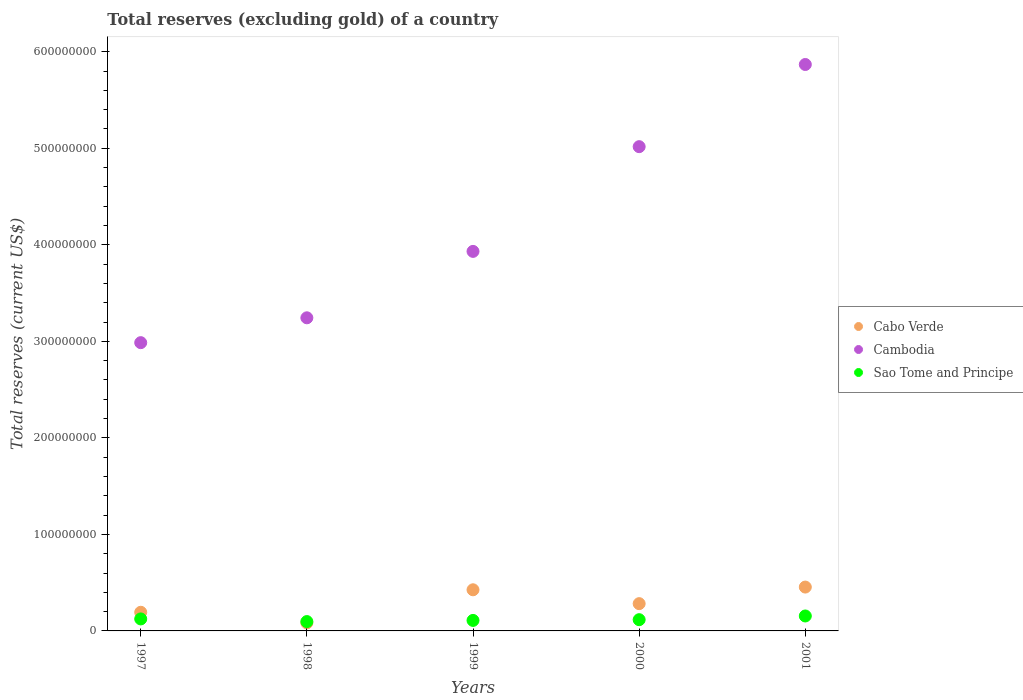What is the total reserves (excluding gold) in Sao Tome and Principe in 2001?
Offer a very short reply. 1.55e+07. Across all years, what is the maximum total reserves (excluding gold) in Sao Tome and Principe?
Ensure brevity in your answer.  1.55e+07. Across all years, what is the minimum total reserves (excluding gold) in Cambodia?
Your answer should be compact. 2.99e+08. In which year was the total reserves (excluding gold) in Cambodia maximum?
Offer a very short reply. 2001. What is the total total reserves (excluding gold) in Cabo Verde in the graph?
Provide a succinct answer. 1.44e+08. What is the difference between the total reserves (excluding gold) in Cambodia in 2000 and that in 2001?
Your answer should be compact. -8.51e+07. What is the difference between the total reserves (excluding gold) in Cabo Verde in 1999 and the total reserves (excluding gold) in Sao Tome and Principe in 2000?
Your answer should be very brief. 3.10e+07. What is the average total reserves (excluding gold) in Sao Tome and Principe per year?
Offer a terse response. 1.20e+07. In the year 2001, what is the difference between the total reserves (excluding gold) in Cabo Verde and total reserves (excluding gold) in Sao Tome and Principe?
Provide a short and direct response. 2.99e+07. What is the ratio of the total reserves (excluding gold) in Sao Tome and Principe in 1998 to that in 1999?
Provide a short and direct response. 0.89. Is the total reserves (excluding gold) in Cabo Verde in 1999 less than that in 2000?
Make the answer very short. No. Is the difference between the total reserves (excluding gold) in Cabo Verde in 1999 and 2000 greater than the difference between the total reserves (excluding gold) in Sao Tome and Principe in 1999 and 2000?
Offer a terse response. Yes. What is the difference between the highest and the second highest total reserves (excluding gold) in Sao Tome and Principe?
Provide a succinct answer. 3.06e+06. What is the difference between the highest and the lowest total reserves (excluding gold) in Sao Tome and Principe?
Provide a short and direct response. 5.80e+06. In how many years, is the total reserves (excluding gold) in Cambodia greater than the average total reserves (excluding gold) in Cambodia taken over all years?
Provide a short and direct response. 2. Is the sum of the total reserves (excluding gold) in Cabo Verde in 1997 and 2001 greater than the maximum total reserves (excluding gold) in Cambodia across all years?
Your response must be concise. No. Is the total reserves (excluding gold) in Cambodia strictly greater than the total reserves (excluding gold) in Sao Tome and Principe over the years?
Your response must be concise. Yes. How many dotlines are there?
Offer a very short reply. 3. What is the difference between two consecutive major ticks on the Y-axis?
Provide a short and direct response. 1.00e+08. Does the graph contain grids?
Give a very brief answer. No. How many legend labels are there?
Your response must be concise. 3. How are the legend labels stacked?
Ensure brevity in your answer.  Vertical. What is the title of the graph?
Offer a terse response. Total reserves (excluding gold) of a country. Does "Sudan" appear as one of the legend labels in the graph?
Your answer should be very brief. No. What is the label or title of the Y-axis?
Make the answer very short. Total reserves (current US$). What is the Total reserves (current US$) of Cabo Verde in 1997?
Your answer should be compact. 1.93e+07. What is the Total reserves (current US$) in Cambodia in 1997?
Give a very brief answer. 2.99e+08. What is the Total reserves (current US$) of Sao Tome and Principe in 1997?
Your answer should be very brief. 1.24e+07. What is the Total reserves (current US$) of Cabo Verde in 1998?
Give a very brief answer. 8.32e+06. What is the Total reserves (current US$) in Cambodia in 1998?
Give a very brief answer. 3.24e+08. What is the Total reserves (current US$) of Sao Tome and Principe in 1998?
Ensure brevity in your answer.  9.68e+06. What is the Total reserves (current US$) of Cabo Verde in 1999?
Offer a very short reply. 4.26e+07. What is the Total reserves (current US$) in Cambodia in 1999?
Offer a terse response. 3.93e+08. What is the Total reserves (current US$) in Sao Tome and Principe in 1999?
Ensure brevity in your answer.  1.09e+07. What is the Total reserves (current US$) of Cabo Verde in 2000?
Ensure brevity in your answer.  2.83e+07. What is the Total reserves (current US$) in Cambodia in 2000?
Provide a short and direct response. 5.02e+08. What is the Total reserves (current US$) in Sao Tome and Principe in 2000?
Your answer should be very brief. 1.16e+07. What is the Total reserves (current US$) in Cabo Verde in 2001?
Ensure brevity in your answer.  4.54e+07. What is the Total reserves (current US$) in Cambodia in 2001?
Provide a short and direct response. 5.87e+08. What is the Total reserves (current US$) of Sao Tome and Principe in 2001?
Ensure brevity in your answer.  1.55e+07. Across all years, what is the maximum Total reserves (current US$) of Cabo Verde?
Your answer should be very brief. 4.54e+07. Across all years, what is the maximum Total reserves (current US$) of Cambodia?
Make the answer very short. 5.87e+08. Across all years, what is the maximum Total reserves (current US$) of Sao Tome and Principe?
Provide a short and direct response. 1.55e+07. Across all years, what is the minimum Total reserves (current US$) in Cabo Verde?
Keep it short and to the point. 8.32e+06. Across all years, what is the minimum Total reserves (current US$) of Cambodia?
Your answer should be compact. 2.99e+08. Across all years, what is the minimum Total reserves (current US$) of Sao Tome and Principe?
Provide a succinct answer. 9.68e+06. What is the total Total reserves (current US$) of Cabo Verde in the graph?
Offer a terse response. 1.44e+08. What is the total Total reserves (current US$) of Cambodia in the graph?
Your answer should be very brief. 2.10e+09. What is the total Total reserves (current US$) of Sao Tome and Principe in the graph?
Provide a short and direct response. 6.01e+07. What is the difference between the Total reserves (current US$) in Cabo Verde in 1997 and that in 1998?
Make the answer very short. 1.10e+07. What is the difference between the Total reserves (current US$) of Cambodia in 1997 and that in 1998?
Your answer should be very brief. -2.57e+07. What is the difference between the Total reserves (current US$) of Sao Tome and Principe in 1997 and that in 1998?
Your response must be concise. 2.74e+06. What is the difference between the Total reserves (current US$) of Cabo Verde in 1997 and that in 1999?
Keep it short and to the point. -2.33e+07. What is the difference between the Total reserves (current US$) of Cambodia in 1997 and that in 1999?
Your answer should be compact. -9.46e+07. What is the difference between the Total reserves (current US$) of Sao Tome and Principe in 1997 and that in 1999?
Your answer should be very brief. 1.55e+06. What is the difference between the Total reserves (current US$) in Cabo Verde in 1997 and that in 2000?
Offer a terse response. -8.93e+06. What is the difference between the Total reserves (current US$) of Cambodia in 1997 and that in 2000?
Keep it short and to the point. -2.03e+08. What is the difference between the Total reserves (current US$) of Sao Tome and Principe in 1997 and that in 2000?
Keep it short and to the point. 7.87e+05. What is the difference between the Total reserves (current US$) of Cabo Verde in 1997 and that in 2001?
Offer a very short reply. -2.61e+07. What is the difference between the Total reserves (current US$) of Cambodia in 1997 and that in 2001?
Your answer should be very brief. -2.88e+08. What is the difference between the Total reserves (current US$) in Sao Tome and Principe in 1997 and that in 2001?
Ensure brevity in your answer.  -3.06e+06. What is the difference between the Total reserves (current US$) of Cabo Verde in 1998 and that in 1999?
Offer a terse response. -3.43e+07. What is the difference between the Total reserves (current US$) of Cambodia in 1998 and that in 1999?
Offer a very short reply. -6.88e+07. What is the difference between the Total reserves (current US$) in Sao Tome and Principe in 1998 and that in 1999?
Your answer should be compact. -1.19e+06. What is the difference between the Total reserves (current US$) in Cabo Verde in 1998 and that in 2000?
Offer a terse response. -1.99e+07. What is the difference between the Total reserves (current US$) in Cambodia in 1998 and that in 2000?
Make the answer very short. -1.77e+08. What is the difference between the Total reserves (current US$) of Sao Tome and Principe in 1998 and that in 2000?
Give a very brief answer. -1.96e+06. What is the difference between the Total reserves (current US$) in Cabo Verde in 1998 and that in 2001?
Make the answer very short. -3.71e+07. What is the difference between the Total reserves (current US$) in Cambodia in 1998 and that in 2001?
Keep it short and to the point. -2.62e+08. What is the difference between the Total reserves (current US$) in Sao Tome and Principe in 1998 and that in 2001?
Provide a short and direct response. -5.80e+06. What is the difference between the Total reserves (current US$) of Cabo Verde in 1999 and that in 2000?
Your answer should be very brief. 1.44e+07. What is the difference between the Total reserves (current US$) of Cambodia in 1999 and that in 2000?
Offer a very short reply. -1.08e+08. What is the difference between the Total reserves (current US$) in Sao Tome and Principe in 1999 and that in 2000?
Give a very brief answer. -7.62e+05. What is the difference between the Total reserves (current US$) in Cabo Verde in 1999 and that in 2001?
Your answer should be compact. -2.81e+06. What is the difference between the Total reserves (current US$) of Cambodia in 1999 and that in 2001?
Your answer should be very brief. -1.94e+08. What is the difference between the Total reserves (current US$) in Sao Tome and Principe in 1999 and that in 2001?
Keep it short and to the point. -4.60e+06. What is the difference between the Total reserves (current US$) in Cabo Verde in 2000 and that in 2001?
Keep it short and to the point. -1.72e+07. What is the difference between the Total reserves (current US$) of Cambodia in 2000 and that in 2001?
Keep it short and to the point. -8.51e+07. What is the difference between the Total reserves (current US$) in Sao Tome and Principe in 2000 and that in 2001?
Offer a terse response. -3.84e+06. What is the difference between the Total reserves (current US$) of Cabo Verde in 1997 and the Total reserves (current US$) of Cambodia in 1998?
Ensure brevity in your answer.  -3.05e+08. What is the difference between the Total reserves (current US$) of Cabo Verde in 1997 and the Total reserves (current US$) of Sao Tome and Principe in 1998?
Your response must be concise. 9.64e+06. What is the difference between the Total reserves (current US$) in Cambodia in 1997 and the Total reserves (current US$) in Sao Tome and Principe in 1998?
Provide a short and direct response. 2.89e+08. What is the difference between the Total reserves (current US$) in Cabo Verde in 1997 and the Total reserves (current US$) in Cambodia in 1999?
Offer a very short reply. -3.74e+08. What is the difference between the Total reserves (current US$) of Cabo Verde in 1997 and the Total reserves (current US$) of Sao Tome and Principe in 1999?
Offer a terse response. 8.45e+06. What is the difference between the Total reserves (current US$) in Cambodia in 1997 and the Total reserves (current US$) in Sao Tome and Principe in 1999?
Offer a terse response. 2.88e+08. What is the difference between the Total reserves (current US$) in Cabo Verde in 1997 and the Total reserves (current US$) in Cambodia in 2000?
Give a very brief answer. -4.82e+08. What is the difference between the Total reserves (current US$) of Cabo Verde in 1997 and the Total reserves (current US$) of Sao Tome and Principe in 2000?
Your answer should be compact. 7.68e+06. What is the difference between the Total reserves (current US$) in Cambodia in 1997 and the Total reserves (current US$) in Sao Tome and Principe in 2000?
Give a very brief answer. 2.87e+08. What is the difference between the Total reserves (current US$) in Cabo Verde in 1997 and the Total reserves (current US$) in Cambodia in 2001?
Provide a succinct answer. -5.67e+08. What is the difference between the Total reserves (current US$) of Cabo Verde in 1997 and the Total reserves (current US$) of Sao Tome and Principe in 2001?
Offer a very short reply. 3.84e+06. What is the difference between the Total reserves (current US$) in Cambodia in 1997 and the Total reserves (current US$) in Sao Tome and Principe in 2001?
Provide a short and direct response. 2.83e+08. What is the difference between the Total reserves (current US$) in Cabo Verde in 1998 and the Total reserves (current US$) in Cambodia in 1999?
Offer a terse response. -3.85e+08. What is the difference between the Total reserves (current US$) of Cabo Verde in 1998 and the Total reserves (current US$) of Sao Tome and Principe in 1999?
Provide a succinct answer. -2.56e+06. What is the difference between the Total reserves (current US$) in Cambodia in 1998 and the Total reserves (current US$) in Sao Tome and Principe in 1999?
Make the answer very short. 3.14e+08. What is the difference between the Total reserves (current US$) of Cabo Verde in 1998 and the Total reserves (current US$) of Cambodia in 2000?
Your response must be concise. -4.93e+08. What is the difference between the Total reserves (current US$) in Cabo Verde in 1998 and the Total reserves (current US$) in Sao Tome and Principe in 2000?
Your response must be concise. -3.32e+06. What is the difference between the Total reserves (current US$) of Cambodia in 1998 and the Total reserves (current US$) of Sao Tome and Principe in 2000?
Offer a terse response. 3.13e+08. What is the difference between the Total reserves (current US$) of Cabo Verde in 1998 and the Total reserves (current US$) of Cambodia in 2001?
Offer a terse response. -5.78e+08. What is the difference between the Total reserves (current US$) of Cabo Verde in 1998 and the Total reserves (current US$) of Sao Tome and Principe in 2001?
Give a very brief answer. -7.16e+06. What is the difference between the Total reserves (current US$) in Cambodia in 1998 and the Total reserves (current US$) in Sao Tome and Principe in 2001?
Offer a very short reply. 3.09e+08. What is the difference between the Total reserves (current US$) of Cabo Verde in 1999 and the Total reserves (current US$) of Cambodia in 2000?
Ensure brevity in your answer.  -4.59e+08. What is the difference between the Total reserves (current US$) of Cabo Verde in 1999 and the Total reserves (current US$) of Sao Tome and Principe in 2000?
Offer a very short reply. 3.10e+07. What is the difference between the Total reserves (current US$) of Cambodia in 1999 and the Total reserves (current US$) of Sao Tome and Principe in 2000?
Provide a short and direct response. 3.82e+08. What is the difference between the Total reserves (current US$) of Cabo Verde in 1999 and the Total reserves (current US$) of Cambodia in 2001?
Provide a short and direct response. -5.44e+08. What is the difference between the Total reserves (current US$) of Cabo Verde in 1999 and the Total reserves (current US$) of Sao Tome and Principe in 2001?
Offer a very short reply. 2.71e+07. What is the difference between the Total reserves (current US$) of Cambodia in 1999 and the Total reserves (current US$) of Sao Tome and Principe in 2001?
Your response must be concise. 3.78e+08. What is the difference between the Total reserves (current US$) of Cabo Verde in 2000 and the Total reserves (current US$) of Cambodia in 2001?
Provide a succinct answer. -5.59e+08. What is the difference between the Total reserves (current US$) in Cabo Verde in 2000 and the Total reserves (current US$) in Sao Tome and Principe in 2001?
Provide a short and direct response. 1.28e+07. What is the difference between the Total reserves (current US$) in Cambodia in 2000 and the Total reserves (current US$) in Sao Tome and Principe in 2001?
Your answer should be compact. 4.86e+08. What is the average Total reserves (current US$) of Cabo Verde per year?
Provide a succinct answer. 2.88e+07. What is the average Total reserves (current US$) in Cambodia per year?
Your response must be concise. 4.21e+08. What is the average Total reserves (current US$) in Sao Tome and Principe per year?
Give a very brief answer. 1.20e+07. In the year 1997, what is the difference between the Total reserves (current US$) in Cabo Verde and Total reserves (current US$) in Cambodia?
Make the answer very short. -2.79e+08. In the year 1997, what is the difference between the Total reserves (current US$) in Cabo Verde and Total reserves (current US$) in Sao Tome and Principe?
Your answer should be compact. 6.90e+06. In the year 1997, what is the difference between the Total reserves (current US$) of Cambodia and Total reserves (current US$) of Sao Tome and Principe?
Keep it short and to the point. 2.86e+08. In the year 1998, what is the difference between the Total reserves (current US$) in Cabo Verde and Total reserves (current US$) in Cambodia?
Offer a terse response. -3.16e+08. In the year 1998, what is the difference between the Total reserves (current US$) of Cabo Verde and Total reserves (current US$) of Sao Tome and Principe?
Your response must be concise. -1.37e+06. In the year 1998, what is the difference between the Total reserves (current US$) in Cambodia and Total reserves (current US$) in Sao Tome and Principe?
Give a very brief answer. 3.15e+08. In the year 1999, what is the difference between the Total reserves (current US$) in Cabo Verde and Total reserves (current US$) in Cambodia?
Offer a terse response. -3.51e+08. In the year 1999, what is the difference between the Total reserves (current US$) in Cabo Verde and Total reserves (current US$) in Sao Tome and Principe?
Make the answer very short. 3.17e+07. In the year 1999, what is the difference between the Total reserves (current US$) in Cambodia and Total reserves (current US$) in Sao Tome and Principe?
Offer a terse response. 3.82e+08. In the year 2000, what is the difference between the Total reserves (current US$) in Cabo Verde and Total reserves (current US$) in Cambodia?
Ensure brevity in your answer.  -4.73e+08. In the year 2000, what is the difference between the Total reserves (current US$) in Cabo Verde and Total reserves (current US$) in Sao Tome and Principe?
Ensure brevity in your answer.  1.66e+07. In the year 2000, what is the difference between the Total reserves (current US$) of Cambodia and Total reserves (current US$) of Sao Tome and Principe?
Offer a very short reply. 4.90e+08. In the year 2001, what is the difference between the Total reserves (current US$) in Cabo Verde and Total reserves (current US$) in Cambodia?
Provide a short and direct response. -5.41e+08. In the year 2001, what is the difference between the Total reserves (current US$) of Cabo Verde and Total reserves (current US$) of Sao Tome and Principe?
Keep it short and to the point. 2.99e+07. In the year 2001, what is the difference between the Total reserves (current US$) in Cambodia and Total reserves (current US$) in Sao Tome and Principe?
Provide a succinct answer. 5.71e+08. What is the ratio of the Total reserves (current US$) in Cabo Verde in 1997 to that in 1998?
Ensure brevity in your answer.  2.32. What is the ratio of the Total reserves (current US$) in Cambodia in 1997 to that in 1998?
Make the answer very short. 0.92. What is the ratio of the Total reserves (current US$) in Sao Tome and Principe in 1997 to that in 1998?
Your response must be concise. 1.28. What is the ratio of the Total reserves (current US$) of Cabo Verde in 1997 to that in 1999?
Ensure brevity in your answer.  0.45. What is the ratio of the Total reserves (current US$) of Cambodia in 1997 to that in 1999?
Your answer should be compact. 0.76. What is the ratio of the Total reserves (current US$) of Sao Tome and Principe in 1997 to that in 1999?
Your answer should be compact. 1.14. What is the ratio of the Total reserves (current US$) of Cabo Verde in 1997 to that in 2000?
Give a very brief answer. 0.68. What is the ratio of the Total reserves (current US$) of Cambodia in 1997 to that in 2000?
Offer a very short reply. 0.6. What is the ratio of the Total reserves (current US$) of Sao Tome and Principe in 1997 to that in 2000?
Offer a terse response. 1.07. What is the ratio of the Total reserves (current US$) in Cabo Verde in 1997 to that in 2001?
Provide a short and direct response. 0.43. What is the ratio of the Total reserves (current US$) of Cambodia in 1997 to that in 2001?
Your response must be concise. 0.51. What is the ratio of the Total reserves (current US$) in Sao Tome and Principe in 1997 to that in 2001?
Make the answer very short. 0.8. What is the ratio of the Total reserves (current US$) in Cabo Verde in 1998 to that in 1999?
Your answer should be very brief. 0.2. What is the ratio of the Total reserves (current US$) in Cambodia in 1998 to that in 1999?
Make the answer very short. 0.82. What is the ratio of the Total reserves (current US$) of Sao Tome and Principe in 1998 to that in 1999?
Offer a very short reply. 0.89. What is the ratio of the Total reserves (current US$) of Cabo Verde in 1998 to that in 2000?
Offer a very short reply. 0.29. What is the ratio of the Total reserves (current US$) in Cambodia in 1998 to that in 2000?
Offer a very short reply. 0.65. What is the ratio of the Total reserves (current US$) in Sao Tome and Principe in 1998 to that in 2000?
Give a very brief answer. 0.83. What is the ratio of the Total reserves (current US$) of Cabo Verde in 1998 to that in 2001?
Your answer should be very brief. 0.18. What is the ratio of the Total reserves (current US$) of Cambodia in 1998 to that in 2001?
Provide a succinct answer. 0.55. What is the ratio of the Total reserves (current US$) of Sao Tome and Principe in 1998 to that in 2001?
Keep it short and to the point. 0.63. What is the ratio of the Total reserves (current US$) in Cabo Verde in 1999 to that in 2000?
Provide a succinct answer. 1.51. What is the ratio of the Total reserves (current US$) in Cambodia in 1999 to that in 2000?
Your answer should be compact. 0.78. What is the ratio of the Total reserves (current US$) of Sao Tome and Principe in 1999 to that in 2000?
Offer a terse response. 0.93. What is the ratio of the Total reserves (current US$) of Cabo Verde in 1999 to that in 2001?
Offer a terse response. 0.94. What is the ratio of the Total reserves (current US$) of Cambodia in 1999 to that in 2001?
Ensure brevity in your answer.  0.67. What is the ratio of the Total reserves (current US$) in Sao Tome and Principe in 1999 to that in 2001?
Provide a succinct answer. 0.7. What is the ratio of the Total reserves (current US$) in Cabo Verde in 2000 to that in 2001?
Make the answer very short. 0.62. What is the ratio of the Total reserves (current US$) in Cambodia in 2000 to that in 2001?
Offer a terse response. 0.85. What is the ratio of the Total reserves (current US$) in Sao Tome and Principe in 2000 to that in 2001?
Ensure brevity in your answer.  0.75. What is the difference between the highest and the second highest Total reserves (current US$) in Cabo Verde?
Keep it short and to the point. 2.81e+06. What is the difference between the highest and the second highest Total reserves (current US$) in Cambodia?
Ensure brevity in your answer.  8.51e+07. What is the difference between the highest and the second highest Total reserves (current US$) in Sao Tome and Principe?
Your response must be concise. 3.06e+06. What is the difference between the highest and the lowest Total reserves (current US$) in Cabo Verde?
Make the answer very short. 3.71e+07. What is the difference between the highest and the lowest Total reserves (current US$) of Cambodia?
Your answer should be compact. 2.88e+08. What is the difference between the highest and the lowest Total reserves (current US$) of Sao Tome and Principe?
Ensure brevity in your answer.  5.80e+06. 